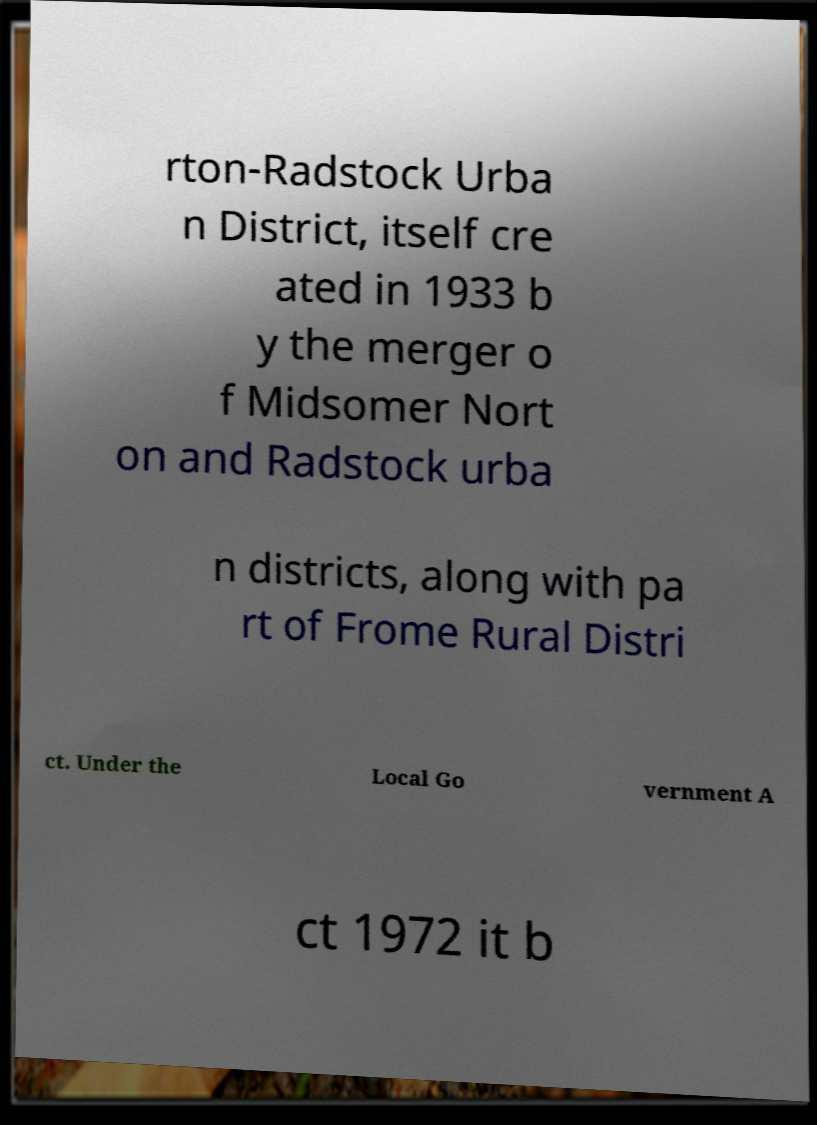There's text embedded in this image that I need extracted. Can you transcribe it verbatim? rton-Radstock Urba n District, itself cre ated in 1933 b y the merger o f Midsomer Nort on and Radstock urba n districts, along with pa rt of Frome Rural Distri ct. Under the Local Go vernment A ct 1972 it b 